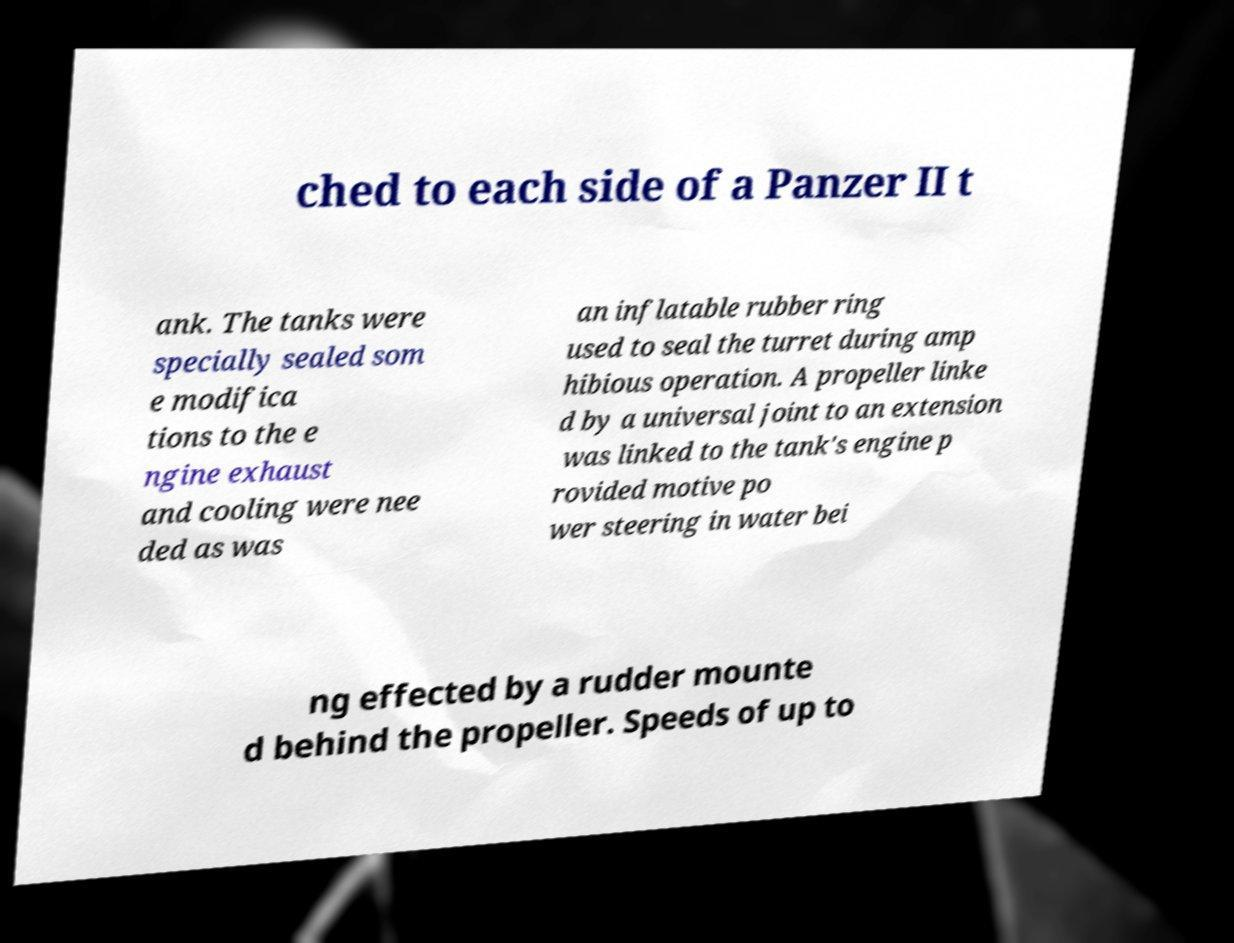I need the written content from this picture converted into text. Can you do that? ched to each side of a Panzer II t ank. The tanks were specially sealed som e modifica tions to the e ngine exhaust and cooling were nee ded as was an inflatable rubber ring used to seal the turret during amp hibious operation. A propeller linke d by a universal joint to an extension was linked to the tank's engine p rovided motive po wer steering in water bei ng effected by a rudder mounte d behind the propeller. Speeds of up to 